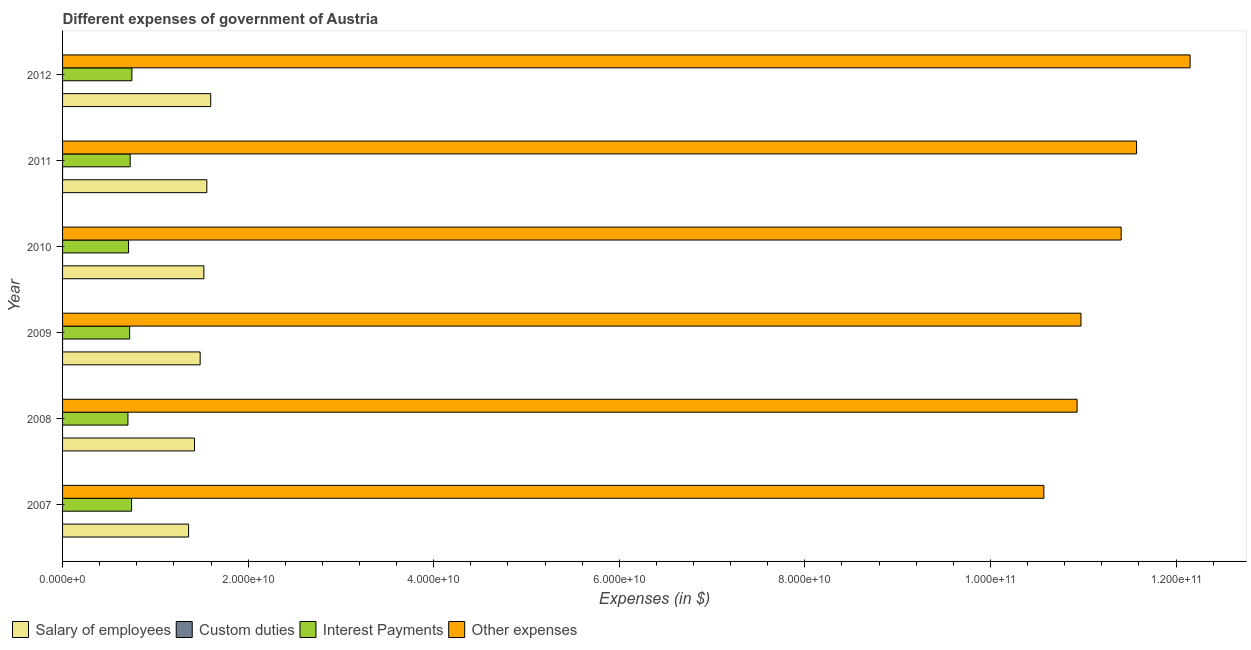How many different coloured bars are there?
Your answer should be very brief. 4. Are the number of bars on each tick of the Y-axis equal?
Provide a succinct answer. No. How many bars are there on the 4th tick from the top?
Provide a succinct answer. 4. How many bars are there on the 6th tick from the bottom?
Offer a terse response. 4. In how many cases, is the number of bars for a given year not equal to the number of legend labels?
Offer a very short reply. 2. What is the amount spent on other expenses in 2012?
Give a very brief answer. 1.22e+11. Across all years, what is the maximum amount spent on interest payments?
Offer a very short reply. 7.47e+09. Across all years, what is the minimum amount spent on other expenses?
Offer a terse response. 1.06e+11. What is the total amount spent on custom duties in the graph?
Your answer should be compact. 3.10e+05. What is the difference between the amount spent on interest payments in 2010 and that in 2011?
Provide a succinct answer. -1.77e+08. What is the difference between the amount spent on other expenses in 2010 and the amount spent on salary of employees in 2011?
Make the answer very short. 9.85e+1. What is the average amount spent on salary of employees per year?
Provide a succinct answer. 1.49e+1. In the year 2010, what is the difference between the amount spent on salary of employees and amount spent on other expenses?
Ensure brevity in your answer.  -9.89e+1. In how many years, is the amount spent on custom duties greater than 92000000000 $?
Offer a very short reply. 0. What is the ratio of the amount spent on other expenses in 2009 to that in 2012?
Keep it short and to the point. 0.9. Is the amount spent on salary of employees in 2009 less than that in 2010?
Give a very brief answer. Yes. What is the difference between the highest and the second highest amount spent on salary of employees?
Provide a short and direct response. 4.19e+08. What is the difference between the highest and the lowest amount spent on custom duties?
Ensure brevity in your answer.  9.00e+04. In how many years, is the amount spent on salary of employees greater than the average amount spent on salary of employees taken over all years?
Provide a short and direct response. 3. Is it the case that in every year, the sum of the amount spent on salary of employees and amount spent on custom duties is greater than the amount spent on interest payments?
Provide a short and direct response. Yes. Are all the bars in the graph horizontal?
Give a very brief answer. Yes. What is the difference between two consecutive major ticks on the X-axis?
Keep it short and to the point. 2.00e+1. Does the graph contain any zero values?
Ensure brevity in your answer.  Yes. Where does the legend appear in the graph?
Ensure brevity in your answer.  Bottom left. What is the title of the graph?
Your answer should be very brief. Different expenses of government of Austria. Does "Quality of logistic services" appear as one of the legend labels in the graph?
Your answer should be compact. No. What is the label or title of the X-axis?
Give a very brief answer. Expenses (in $). What is the label or title of the Y-axis?
Your answer should be compact. Year. What is the Expenses (in $) in Salary of employees in 2007?
Ensure brevity in your answer.  1.36e+1. What is the Expenses (in $) of Custom duties in 2007?
Your answer should be very brief. 0. What is the Expenses (in $) of Interest Payments in 2007?
Ensure brevity in your answer.  7.44e+09. What is the Expenses (in $) in Other expenses in 2007?
Your response must be concise. 1.06e+11. What is the Expenses (in $) of Salary of employees in 2008?
Your answer should be very brief. 1.42e+1. What is the Expenses (in $) of Custom duties in 2008?
Provide a short and direct response. 0. What is the Expenses (in $) of Interest Payments in 2008?
Your response must be concise. 7.04e+09. What is the Expenses (in $) in Other expenses in 2008?
Your response must be concise. 1.09e+11. What is the Expenses (in $) in Salary of employees in 2009?
Provide a succinct answer. 1.48e+1. What is the Expenses (in $) in Custom duties in 2009?
Keep it short and to the point. 7.00e+04. What is the Expenses (in $) of Interest Payments in 2009?
Make the answer very short. 7.23e+09. What is the Expenses (in $) in Other expenses in 2009?
Ensure brevity in your answer.  1.10e+11. What is the Expenses (in $) of Salary of employees in 2010?
Offer a very short reply. 1.52e+1. What is the Expenses (in $) of Interest Payments in 2010?
Your answer should be very brief. 7.11e+09. What is the Expenses (in $) of Other expenses in 2010?
Keep it short and to the point. 1.14e+11. What is the Expenses (in $) in Salary of employees in 2011?
Your answer should be very brief. 1.55e+1. What is the Expenses (in $) of Custom duties in 2011?
Give a very brief answer. 8.00e+04. What is the Expenses (in $) in Interest Payments in 2011?
Offer a terse response. 7.29e+09. What is the Expenses (in $) of Other expenses in 2011?
Make the answer very short. 1.16e+11. What is the Expenses (in $) of Salary of employees in 2012?
Your response must be concise. 1.60e+1. What is the Expenses (in $) in Interest Payments in 2012?
Your answer should be compact. 7.47e+09. What is the Expenses (in $) of Other expenses in 2012?
Give a very brief answer. 1.22e+11. Across all years, what is the maximum Expenses (in $) of Salary of employees?
Provide a short and direct response. 1.60e+1. Across all years, what is the maximum Expenses (in $) in Interest Payments?
Ensure brevity in your answer.  7.47e+09. Across all years, what is the maximum Expenses (in $) in Other expenses?
Your response must be concise. 1.22e+11. Across all years, what is the minimum Expenses (in $) of Salary of employees?
Your answer should be compact. 1.36e+1. Across all years, what is the minimum Expenses (in $) of Custom duties?
Your response must be concise. 0. Across all years, what is the minimum Expenses (in $) in Interest Payments?
Keep it short and to the point. 7.04e+09. Across all years, what is the minimum Expenses (in $) of Other expenses?
Ensure brevity in your answer.  1.06e+11. What is the total Expenses (in $) in Salary of employees in the graph?
Ensure brevity in your answer.  8.94e+1. What is the total Expenses (in $) in Interest Payments in the graph?
Provide a succinct answer. 4.36e+1. What is the total Expenses (in $) of Other expenses in the graph?
Provide a short and direct response. 6.76e+11. What is the difference between the Expenses (in $) in Salary of employees in 2007 and that in 2008?
Make the answer very short. -6.39e+08. What is the difference between the Expenses (in $) of Interest Payments in 2007 and that in 2008?
Offer a terse response. 3.92e+08. What is the difference between the Expenses (in $) in Other expenses in 2007 and that in 2008?
Ensure brevity in your answer.  -3.58e+09. What is the difference between the Expenses (in $) of Salary of employees in 2007 and that in 2009?
Offer a very short reply. -1.25e+09. What is the difference between the Expenses (in $) in Interest Payments in 2007 and that in 2009?
Provide a succinct answer. 2.08e+08. What is the difference between the Expenses (in $) of Other expenses in 2007 and that in 2009?
Offer a terse response. -4.00e+09. What is the difference between the Expenses (in $) in Salary of employees in 2007 and that in 2010?
Offer a terse response. -1.65e+09. What is the difference between the Expenses (in $) of Interest Payments in 2007 and that in 2010?
Offer a very short reply. 3.25e+08. What is the difference between the Expenses (in $) of Other expenses in 2007 and that in 2010?
Your response must be concise. -8.33e+09. What is the difference between the Expenses (in $) in Salary of employees in 2007 and that in 2011?
Give a very brief answer. -1.97e+09. What is the difference between the Expenses (in $) of Interest Payments in 2007 and that in 2011?
Give a very brief answer. 1.47e+08. What is the difference between the Expenses (in $) of Other expenses in 2007 and that in 2011?
Make the answer very short. -9.99e+09. What is the difference between the Expenses (in $) in Salary of employees in 2007 and that in 2012?
Provide a succinct answer. -2.38e+09. What is the difference between the Expenses (in $) of Interest Payments in 2007 and that in 2012?
Give a very brief answer. -3.60e+07. What is the difference between the Expenses (in $) of Other expenses in 2007 and that in 2012?
Provide a short and direct response. -1.58e+1. What is the difference between the Expenses (in $) of Salary of employees in 2008 and that in 2009?
Provide a short and direct response. -6.08e+08. What is the difference between the Expenses (in $) of Interest Payments in 2008 and that in 2009?
Your answer should be compact. -1.84e+08. What is the difference between the Expenses (in $) of Other expenses in 2008 and that in 2009?
Ensure brevity in your answer.  -4.19e+08. What is the difference between the Expenses (in $) in Salary of employees in 2008 and that in 2010?
Provide a short and direct response. -1.01e+09. What is the difference between the Expenses (in $) of Interest Payments in 2008 and that in 2010?
Your response must be concise. -6.76e+07. What is the difference between the Expenses (in $) of Other expenses in 2008 and that in 2010?
Ensure brevity in your answer.  -4.75e+09. What is the difference between the Expenses (in $) of Salary of employees in 2008 and that in 2011?
Your response must be concise. -1.33e+09. What is the difference between the Expenses (in $) of Interest Payments in 2008 and that in 2011?
Provide a short and direct response. -2.45e+08. What is the difference between the Expenses (in $) of Other expenses in 2008 and that in 2011?
Give a very brief answer. -6.41e+09. What is the difference between the Expenses (in $) of Salary of employees in 2008 and that in 2012?
Give a very brief answer. -1.75e+09. What is the difference between the Expenses (in $) in Interest Payments in 2008 and that in 2012?
Make the answer very short. -4.28e+08. What is the difference between the Expenses (in $) in Other expenses in 2008 and that in 2012?
Keep it short and to the point. -1.22e+1. What is the difference between the Expenses (in $) of Salary of employees in 2009 and that in 2010?
Your answer should be very brief. -3.99e+08. What is the difference between the Expenses (in $) of Interest Payments in 2009 and that in 2010?
Your answer should be compact. 1.17e+08. What is the difference between the Expenses (in $) of Other expenses in 2009 and that in 2010?
Make the answer very short. -4.33e+09. What is the difference between the Expenses (in $) in Salary of employees in 2009 and that in 2011?
Ensure brevity in your answer.  -7.19e+08. What is the difference between the Expenses (in $) in Interest Payments in 2009 and that in 2011?
Give a very brief answer. -6.07e+07. What is the difference between the Expenses (in $) of Other expenses in 2009 and that in 2011?
Give a very brief answer. -5.99e+09. What is the difference between the Expenses (in $) in Salary of employees in 2009 and that in 2012?
Keep it short and to the point. -1.14e+09. What is the difference between the Expenses (in $) of Interest Payments in 2009 and that in 2012?
Keep it short and to the point. -2.44e+08. What is the difference between the Expenses (in $) in Other expenses in 2009 and that in 2012?
Provide a short and direct response. -1.18e+1. What is the difference between the Expenses (in $) in Salary of employees in 2010 and that in 2011?
Provide a short and direct response. -3.20e+08. What is the difference between the Expenses (in $) in Interest Payments in 2010 and that in 2011?
Offer a very short reply. -1.77e+08. What is the difference between the Expenses (in $) of Other expenses in 2010 and that in 2011?
Keep it short and to the point. -1.66e+09. What is the difference between the Expenses (in $) of Salary of employees in 2010 and that in 2012?
Offer a very short reply. -7.39e+08. What is the difference between the Expenses (in $) in Custom duties in 2010 and that in 2012?
Provide a short and direct response. 2.00e+04. What is the difference between the Expenses (in $) of Interest Payments in 2010 and that in 2012?
Your answer should be very brief. -3.61e+08. What is the difference between the Expenses (in $) in Other expenses in 2010 and that in 2012?
Offer a very short reply. -7.43e+09. What is the difference between the Expenses (in $) in Salary of employees in 2011 and that in 2012?
Make the answer very short. -4.19e+08. What is the difference between the Expenses (in $) in Interest Payments in 2011 and that in 2012?
Your answer should be very brief. -1.83e+08. What is the difference between the Expenses (in $) in Other expenses in 2011 and that in 2012?
Your response must be concise. -5.77e+09. What is the difference between the Expenses (in $) in Salary of employees in 2007 and the Expenses (in $) in Interest Payments in 2008?
Keep it short and to the point. 6.54e+09. What is the difference between the Expenses (in $) in Salary of employees in 2007 and the Expenses (in $) in Other expenses in 2008?
Give a very brief answer. -9.58e+1. What is the difference between the Expenses (in $) in Interest Payments in 2007 and the Expenses (in $) in Other expenses in 2008?
Make the answer very short. -1.02e+11. What is the difference between the Expenses (in $) of Salary of employees in 2007 and the Expenses (in $) of Custom duties in 2009?
Provide a short and direct response. 1.36e+1. What is the difference between the Expenses (in $) of Salary of employees in 2007 and the Expenses (in $) of Interest Payments in 2009?
Ensure brevity in your answer.  6.35e+09. What is the difference between the Expenses (in $) of Salary of employees in 2007 and the Expenses (in $) of Other expenses in 2009?
Make the answer very short. -9.62e+1. What is the difference between the Expenses (in $) of Interest Payments in 2007 and the Expenses (in $) of Other expenses in 2009?
Your answer should be compact. -1.02e+11. What is the difference between the Expenses (in $) of Salary of employees in 2007 and the Expenses (in $) of Custom duties in 2010?
Provide a short and direct response. 1.36e+1. What is the difference between the Expenses (in $) of Salary of employees in 2007 and the Expenses (in $) of Interest Payments in 2010?
Offer a very short reply. 6.47e+09. What is the difference between the Expenses (in $) in Salary of employees in 2007 and the Expenses (in $) in Other expenses in 2010?
Provide a short and direct response. -1.01e+11. What is the difference between the Expenses (in $) of Interest Payments in 2007 and the Expenses (in $) of Other expenses in 2010?
Offer a very short reply. -1.07e+11. What is the difference between the Expenses (in $) in Salary of employees in 2007 and the Expenses (in $) in Custom duties in 2011?
Provide a succinct answer. 1.36e+1. What is the difference between the Expenses (in $) of Salary of employees in 2007 and the Expenses (in $) of Interest Payments in 2011?
Give a very brief answer. 6.29e+09. What is the difference between the Expenses (in $) in Salary of employees in 2007 and the Expenses (in $) in Other expenses in 2011?
Ensure brevity in your answer.  -1.02e+11. What is the difference between the Expenses (in $) in Interest Payments in 2007 and the Expenses (in $) in Other expenses in 2011?
Provide a succinct answer. -1.08e+11. What is the difference between the Expenses (in $) of Salary of employees in 2007 and the Expenses (in $) of Custom duties in 2012?
Keep it short and to the point. 1.36e+1. What is the difference between the Expenses (in $) in Salary of employees in 2007 and the Expenses (in $) in Interest Payments in 2012?
Your answer should be very brief. 6.11e+09. What is the difference between the Expenses (in $) of Salary of employees in 2007 and the Expenses (in $) of Other expenses in 2012?
Your answer should be very brief. -1.08e+11. What is the difference between the Expenses (in $) of Interest Payments in 2007 and the Expenses (in $) of Other expenses in 2012?
Your answer should be compact. -1.14e+11. What is the difference between the Expenses (in $) in Salary of employees in 2008 and the Expenses (in $) in Custom duties in 2009?
Your response must be concise. 1.42e+1. What is the difference between the Expenses (in $) of Salary of employees in 2008 and the Expenses (in $) of Interest Payments in 2009?
Provide a succinct answer. 6.99e+09. What is the difference between the Expenses (in $) in Salary of employees in 2008 and the Expenses (in $) in Other expenses in 2009?
Your answer should be compact. -9.55e+1. What is the difference between the Expenses (in $) of Interest Payments in 2008 and the Expenses (in $) of Other expenses in 2009?
Provide a succinct answer. -1.03e+11. What is the difference between the Expenses (in $) in Salary of employees in 2008 and the Expenses (in $) in Custom duties in 2010?
Provide a short and direct response. 1.42e+1. What is the difference between the Expenses (in $) of Salary of employees in 2008 and the Expenses (in $) of Interest Payments in 2010?
Make the answer very short. 7.11e+09. What is the difference between the Expenses (in $) of Salary of employees in 2008 and the Expenses (in $) of Other expenses in 2010?
Keep it short and to the point. -9.99e+1. What is the difference between the Expenses (in $) of Interest Payments in 2008 and the Expenses (in $) of Other expenses in 2010?
Your answer should be compact. -1.07e+11. What is the difference between the Expenses (in $) in Salary of employees in 2008 and the Expenses (in $) in Custom duties in 2011?
Provide a short and direct response. 1.42e+1. What is the difference between the Expenses (in $) in Salary of employees in 2008 and the Expenses (in $) in Interest Payments in 2011?
Offer a very short reply. 6.93e+09. What is the difference between the Expenses (in $) of Salary of employees in 2008 and the Expenses (in $) of Other expenses in 2011?
Make the answer very short. -1.02e+11. What is the difference between the Expenses (in $) in Interest Payments in 2008 and the Expenses (in $) in Other expenses in 2011?
Offer a terse response. -1.09e+11. What is the difference between the Expenses (in $) in Salary of employees in 2008 and the Expenses (in $) in Custom duties in 2012?
Give a very brief answer. 1.42e+1. What is the difference between the Expenses (in $) in Salary of employees in 2008 and the Expenses (in $) in Interest Payments in 2012?
Your answer should be compact. 6.75e+09. What is the difference between the Expenses (in $) of Salary of employees in 2008 and the Expenses (in $) of Other expenses in 2012?
Make the answer very short. -1.07e+11. What is the difference between the Expenses (in $) of Interest Payments in 2008 and the Expenses (in $) of Other expenses in 2012?
Your answer should be compact. -1.14e+11. What is the difference between the Expenses (in $) in Salary of employees in 2009 and the Expenses (in $) in Custom duties in 2010?
Make the answer very short. 1.48e+1. What is the difference between the Expenses (in $) of Salary of employees in 2009 and the Expenses (in $) of Interest Payments in 2010?
Your answer should be compact. 7.72e+09. What is the difference between the Expenses (in $) in Salary of employees in 2009 and the Expenses (in $) in Other expenses in 2010?
Provide a short and direct response. -9.93e+1. What is the difference between the Expenses (in $) in Custom duties in 2009 and the Expenses (in $) in Interest Payments in 2010?
Make the answer very short. -7.11e+09. What is the difference between the Expenses (in $) in Custom duties in 2009 and the Expenses (in $) in Other expenses in 2010?
Provide a short and direct response. -1.14e+11. What is the difference between the Expenses (in $) of Interest Payments in 2009 and the Expenses (in $) of Other expenses in 2010?
Ensure brevity in your answer.  -1.07e+11. What is the difference between the Expenses (in $) of Salary of employees in 2009 and the Expenses (in $) of Custom duties in 2011?
Provide a succinct answer. 1.48e+1. What is the difference between the Expenses (in $) of Salary of employees in 2009 and the Expenses (in $) of Interest Payments in 2011?
Offer a terse response. 7.54e+09. What is the difference between the Expenses (in $) of Salary of employees in 2009 and the Expenses (in $) of Other expenses in 2011?
Offer a very short reply. -1.01e+11. What is the difference between the Expenses (in $) of Custom duties in 2009 and the Expenses (in $) of Interest Payments in 2011?
Your answer should be compact. -7.29e+09. What is the difference between the Expenses (in $) of Custom duties in 2009 and the Expenses (in $) of Other expenses in 2011?
Your answer should be very brief. -1.16e+11. What is the difference between the Expenses (in $) in Interest Payments in 2009 and the Expenses (in $) in Other expenses in 2011?
Keep it short and to the point. -1.09e+11. What is the difference between the Expenses (in $) of Salary of employees in 2009 and the Expenses (in $) of Custom duties in 2012?
Keep it short and to the point. 1.48e+1. What is the difference between the Expenses (in $) in Salary of employees in 2009 and the Expenses (in $) in Interest Payments in 2012?
Your answer should be very brief. 7.36e+09. What is the difference between the Expenses (in $) in Salary of employees in 2009 and the Expenses (in $) in Other expenses in 2012?
Ensure brevity in your answer.  -1.07e+11. What is the difference between the Expenses (in $) in Custom duties in 2009 and the Expenses (in $) in Interest Payments in 2012?
Provide a succinct answer. -7.47e+09. What is the difference between the Expenses (in $) in Custom duties in 2009 and the Expenses (in $) in Other expenses in 2012?
Your response must be concise. -1.22e+11. What is the difference between the Expenses (in $) in Interest Payments in 2009 and the Expenses (in $) in Other expenses in 2012?
Offer a very short reply. -1.14e+11. What is the difference between the Expenses (in $) in Salary of employees in 2010 and the Expenses (in $) in Custom duties in 2011?
Ensure brevity in your answer.  1.52e+1. What is the difference between the Expenses (in $) of Salary of employees in 2010 and the Expenses (in $) of Interest Payments in 2011?
Your answer should be compact. 7.94e+09. What is the difference between the Expenses (in $) of Salary of employees in 2010 and the Expenses (in $) of Other expenses in 2011?
Keep it short and to the point. -1.01e+11. What is the difference between the Expenses (in $) of Custom duties in 2010 and the Expenses (in $) of Interest Payments in 2011?
Offer a terse response. -7.29e+09. What is the difference between the Expenses (in $) of Custom duties in 2010 and the Expenses (in $) of Other expenses in 2011?
Your answer should be very brief. -1.16e+11. What is the difference between the Expenses (in $) of Interest Payments in 2010 and the Expenses (in $) of Other expenses in 2011?
Make the answer very short. -1.09e+11. What is the difference between the Expenses (in $) of Salary of employees in 2010 and the Expenses (in $) of Custom duties in 2012?
Your answer should be very brief. 1.52e+1. What is the difference between the Expenses (in $) of Salary of employees in 2010 and the Expenses (in $) of Interest Payments in 2012?
Make the answer very short. 7.76e+09. What is the difference between the Expenses (in $) in Salary of employees in 2010 and the Expenses (in $) in Other expenses in 2012?
Ensure brevity in your answer.  -1.06e+11. What is the difference between the Expenses (in $) in Custom duties in 2010 and the Expenses (in $) in Interest Payments in 2012?
Your response must be concise. -7.47e+09. What is the difference between the Expenses (in $) of Custom duties in 2010 and the Expenses (in $) of Other expenses in 2012?
Offer a terse response. -1.22e+11. What is the difference between the Expenses (in $) in Interest Payments in 2010 and the Expenses (in $) in Other expenses in 2012?
Your answer should be compact. -1.14e+11. What is the difference between the Expenses (in $) in Salary of employees in 2011 and the Expenses (in $) in Custom duties in 2012?
Your answer should be compact. 1.55e+1. What is the difference between the Expenses (in $) in Salary of employees in 2011 and the Expenses (in $) in Interest Payments in 2012?
Keep it short and to the point. 8.08e+09. What is the difference between the Expenses (in $) of Salary of employees in 2011 and the Expenses (in $) of Other expenses in 2012?
Ensure brevity in your answer.  -1.06e+11. What is the difference between the Expenses (in $) in Custom duties in 2011 and the Expenses (in $) in Interest Payments in 2012?
Give a very brief answer. -7.47e+09. What is the difference between the Expenses (in $) of Custom duties in 2011 and the Expenses (in $) of Other expenses in 2012?
Give a very brief answer. -1.22e+11. What is the difference between the Expenses (in $) in Interest Payments in 2011 and the Expenses (in $) in Other expenses in 2012?
Your answer should be very brief. -1.14e+11. What is the average Expenses (in $) in Salary of employees per year?
Keep it short and to the point. 1.49e+1. What is the average Expenses (in $) in Custom duties per year?
Keep it short and to the point. 5.17e+04. What is the average Expenses (in $) of Interest Payments per year?
Your answer should be very brief. 7.26e+09. What is the average Expenses (in $) in Other expenses per year?
Offer a very short reply. 1.13e+11. In the year 2007, what is the difference between the Expenses (in $) in Salary of employees and Expenses (in $) in Interest Payments?
Offer a very short reply. 6.15e+09. In the year 2007, what is the difference between the Expenses (in $) of Salary of employees and Expenses (in $) of Other expenses?
Give a very brief answer. -9.22e+1. In the year 2007, what is the difference between the Expenses (in $) in Interest Payments and Expenses (in $) in Other expenses?
Make the answer very short. -9.83e+1. In the year 2008, what is the difference between the Expenses (in $) in Salary of employees and Expenses (in $) in Interest Payments?
Your response must be concise. 7.18e+09. In the year 2008, what is the difference between the Expenses (in $) in Salary of employees and Expenses (in $) in Other expenses?
Your answer should be very brief. -9.51e+1. In the year 2008, what is the difference between the Expenses (in $) in Interest Payments and Expenses (in $) in Other expenses?
Make the answer very short. -1.02e+11. In the year 2009, what is the difference between the Expenses (in $) of Salary of employees and Expenses (in $) of Custom duties?
Offer a terse response. 1.48e+1. In the year 2009, what is the difference between the Expenses (in $) of Salary of employees and Expenses (in $) of Interest Payments?
Offer a terse response. 7.60e+09. In the year 2009, what is the difference between the Expenses (in $) in Salary of employees and Expenses (in $) in Other expenses?
Make the answer very short. -9.49e+1. In the year 2009, what is the difference between the Expenses (in $) in Custom duties and Expenses (in $) in Interest Payments?
Provide a short and direct response. -7.23e+09. In the year 2009, what is the difference between the Expenses (in $) of Custom duties and Expenses (in $) of Other expenses?
Keep it short and to the point. -1.10e+11. In the year 2009, what is the difference between the Expenses (in $) in Interest Payments and Expenses (in $) in Other expenses?
Ensure brevity in your answer.  -1.03e+11. In the year 2010, what is the difference between the Expenses (in $) of Salary of employees and Expenses (in $) of Custom duties?
Offer a very short reply. 1.52e+1. In the year 2010, what is the difference between the Expenses (in $) of Salary of employees and Expenses (in $) of Interest Payments?
Your response must be concise. 8.12e+09. In the year 2010, what is the difference between the Expenses (in $) in Salary of employees and Expenses (in $) in Other expenses?
Your answer should be compact. -9.89e+1. In the year 2010, what is the difference between the Expenses (in $) of Custom duties and Expenses (in $) of Interest Payments?
Provide a succinct answer. -7.11e+09. In the year 2010, what is the difference between the Expenses (in $) of Custom duties and Expenses (in $) of Other expenses?
Make the answer very short. -1.14e+11. In the year 2010, what is the difference between the Expenses (in $) in Interest Payments and Expenses (in $) in Other expenses?
Offer a terse response. -1.07e+11. In the year 2011, what is the difference between the Expenses (in $) in Salary of employees and Expenses (in $) in Custom duties?
Provide a succinct answer. 1.55e+1. In the year 2011, what is the difference between the Expenses (in $) in Salary of employees and Expenses (in $) in Interest Payments?
Your answer should be compact. 8.26e+09. In the year 2011, what is the difference between the Expenses (in $) of Salary of employees and Expenses (in $) of Other expenses?
Your answer should be very brief. -1.00e+11. In the year 2011, what is the difference between the Expenses (in $) of Custom duties and Expenses (in $) of Interest Payments?
Your answer should be very brief. -7.29e+09. In the year 2011, what is the difference between the Expenses (in $) in Custom duties and Expenses (in $) in Other expenses?
Provide a short and direct response. -1.16e+11. In the year 2011, what is the difference between the Expenses (in $) of Interest Payments and Expenses (in $) of Other expenses?
Keep it short and to the point. -1.08e+11. In the year 2012, what is the difference between the Expenses (in $) of Salary of employees and Expenses (in $) of Custom duties?
Offer a very short reply. 1.60e+1. In the year 2012, what is the difference between the Expenses (in $) in Salary of employees and Expenses (in $) in Interest Payments?
Offer a terse response. 8.49e+09. In the year 2012, what is the difference between the Expenses (in $) of Salary of employees and Expenses (in $) of Other expenses?
Your response must be concise. -1.06e+11. In the year 2012, what is the difference between the Expenses (in $) of Custom duties and Expenses (in $) of Interest Payments?
Provide a short and direct response. -7.47e+09. In the year 2012, what is the difference between the Expenses (in $) in Custom duties and Expenses (in $) in Other expenses?
Ensure brevity in your answer.  -1.22e+11. In the year 2012, what is the difference between the Expenses (in $) of Interest Payments and Expenses (in $) of Other expenses?
Ensure brevity in your answer.  -1.14e+11. What is the ratio of the Expenses (in $) in Salary of employees in 2007 to that in 2008?
Your response must be concise. 0.96. What is the ratio of the Expenses (in $) of Interest Payments in 2007 to that in 2008?
Offer a terse response. 1.06. What is the ratio of the Expenses (in $) of Other expenses in 2007 to that in 2008?
Give a very brief answer. 0.97. What is the ratio of the Expenses (in $) of Salary of employees in 2007 to that in 2009?
Ensure brevity in your answer.  0.92. What is the ratio of the Expenses (in $) of Interest Payments in 2007 to that in 2009?
Keep it short and to the point. 1.03. What is the ratio of the Expenses (in $) in Other expenses in 2007 to that in 2009?
Offer a very short reply. 0.96. What is the ratio of the Expenses (in $) in Salary of employees in 2007 to that in 2010?
Make the answer very short. 0.89. What is the ratio of the Expenses (in $) of Interest Payments in 2007 to that in 2010?
Offer a terse response. 1.05. What is the ratio of the Expenses (in $) of Other expenses in 2007 to that in 2010?
Your response must be concise. 0.93. What is the ratio of the Expenses (in $) in Salary of employees in 2007 to that in 2011?
Provide a short and direct response. 0.87. What is the ratio of the Expenses (in $) of Interest Payments in 2007 to that in 2011?
Offer a terse response. 1.02. What is the ratio of the Expenses (in $) of Other expenses in 2007 to that in 2011?
Offer a very short reply. 0.91. What is the ratio of the Expenses (in $) of Salary of employees in 2007 to that in 2012?
Provide a succinct answer. 0.85. What is the ratio of the Expenses (in $) in Interest Payments in 2007 to that in 2012?
Offer a very short reply. 1. What is the ratio of the Expenses (in $) of Other expenses in 2007 to that in 2012?
Your response must be concise. 0.87. What is the ratio of the Expenses (in $) in Salary of employees in 2008 to that in 2009?
Your response must be concise. 0.96. What is the ratio of the Expenses (in $) in Interest Payments in 2008 to that in 2009?
Offer a terse response. 0.97. What is the ratio of the Expenses (in $) of Salary of employees in 2008 to that in 2010?
Provide a short and direct response. 0.93. What is the ratio of the Expenses (in $) in Interest Payments in 2008 to that in 2010?
Give a very brief answer. 0.99. What is the ratio of the Expenses (in $) in Other expenses in 2008 to that in 2010?
Offer a terse response. 0.96. What is the ratio of the Expenses (in $) in Salary of employees in 2008 to that in 2011?
Provide a succinct answer. 0.91. What is the ratio of the Expenses (in $) of Interest Payments in 2008 to that in 2011?
Keep it short and to the point. 0.97. What is the ratio of the Expenses (in $) of Other expenses in 2008 to that in 2011?
Provide a succinct answer. 0.94. What is the ratio of the Expenses (in $) in Salary of employees in 2008 to that in 2012?
Make the answer very short. 0.89. What is the ratio of the Expenses (in $) in Interest Payments in 2008 to that in 2012?
Keep it short and to the point. 0.94. What is the ratio of the Expenses (in $) of Other expenses in 2008 to that in 2012?
Keep it short and to the point. 0.9. What is the ratio of the Expenses (in $) in Salary of employees in 2009 to that in 2010?
Your answer should be compact. 0.97. What is the ratio of the Expenses (in $) of Custom duties in 2009 to that in 2010?
Keep it short and to the point. 0.78. What is the ratio of the Expenses (in $) of Interest Payments in 2009 to that in 2010?
Your answer should be very brief. 1.02. What is the ratio of the Expenses (in $) of Other expenses in 2009 to that in 2010?
Provide a short and direct response. 0.96. What is the ratio of the Expenses (in $) in Salary of employees in 2009 to that in 2011?
Make the answer very short. 0.95. What is the ratio of the Expenses (in $) in Interest Payments in 2009 to that in 2011?
Offer a very short reply. 0.99. What is the ratio of the Expenses (in $) in Other expenses in 2009 to that in 2011?
Offer a very short reply. 0.95. What is the ratio of the Expenses (in $) in Salary of employees in 2009 to that in 2012?
Offer a very short reply. 0.93. What is the ratio of the Expenses (in $) in Custom duties in 2009 to that in 2012?
Your response must be concise. 1. What is the ratio of the Expenses (in $) of Interest Payments in 2009 to that in 2012?
Ensure brevity in your answer.  0.97. What is the ratio of the Expenses (in $) in Other expenses in 2009 to that in 2012?
Your response must be concise. 0.9. What is the ratio of the Expenses (in $) of Salary of employees in 2010 to that in 2011?
Ensure brevity in your answer.  0.98. What is the ratio of the Expenses (in $) of Custom duties in 2010 to that in 2011?
Make the answer very short. 1.12. What is the ratio of the Expenses (in $) in Interest Payments in 2010 to that in 2011?
Offer a terse response. 0.98. What is the ratio of the Expenses (in $) in Other expenses in 2010 to that in 2011?
Ensure brevity in your answer.  0.99. What is the ratio of the Expenses (in $) of Salary of employees in 2010 to that in 2012?
Your response must be concise. 0.95. What is the ratio of the Expenses (in $) of Interest Payments in 2010 to that in 2012?
Ensure brevity in your answer.  0.95. What is the ratio of the Expenses (in $) in Other expenses in 2010 to that in 2012?
Ensure brevity in your answer.  0.94. What is the ratio of the Expenses (in $) of Salary of employees in 2011 to that in 2012?
Provide a succinct answer. 0.97. What is the ratio of the Expenses (in $) of Interest Payments in 2011 to that in 2012?
Provide a short and direct response. 0.98. What is the ratio of the Expenses (in $) of Other expenses in 2011 to that in 2012?
Your answer should be compact. 0.95. What is the difference between the highest and the second highest Expenses (in $) in Salary of employees?
Ensure brevity in your answer.  4.19e+08. What is the difference between the highest and the second highest Expenses (in $) of Interest Payments?
Ensure brevity in your answer.  3.60e+07. What is the difference between the highest and the second highest Expenses (in $) of Other expenses?
Your answer should be compact. 5.77e+09. What is the difference between the highest and the lowest Expenses (in $) in Salary of employees?
Offer a terse response. 2.38e+09. What is the difference between the highest and the lowest Expenses (in $) of Custom duties?
Your response must be concise. 9.00e+04. What is the difference between the highest and the lowest Expenses (in $) of Interest Payments?
Your answer should be compact. 4.28e+08. What is the difference between the highest and the lowest Expenses (in $) of Other expenses?
Your response must be concise. 1.58e+1. 